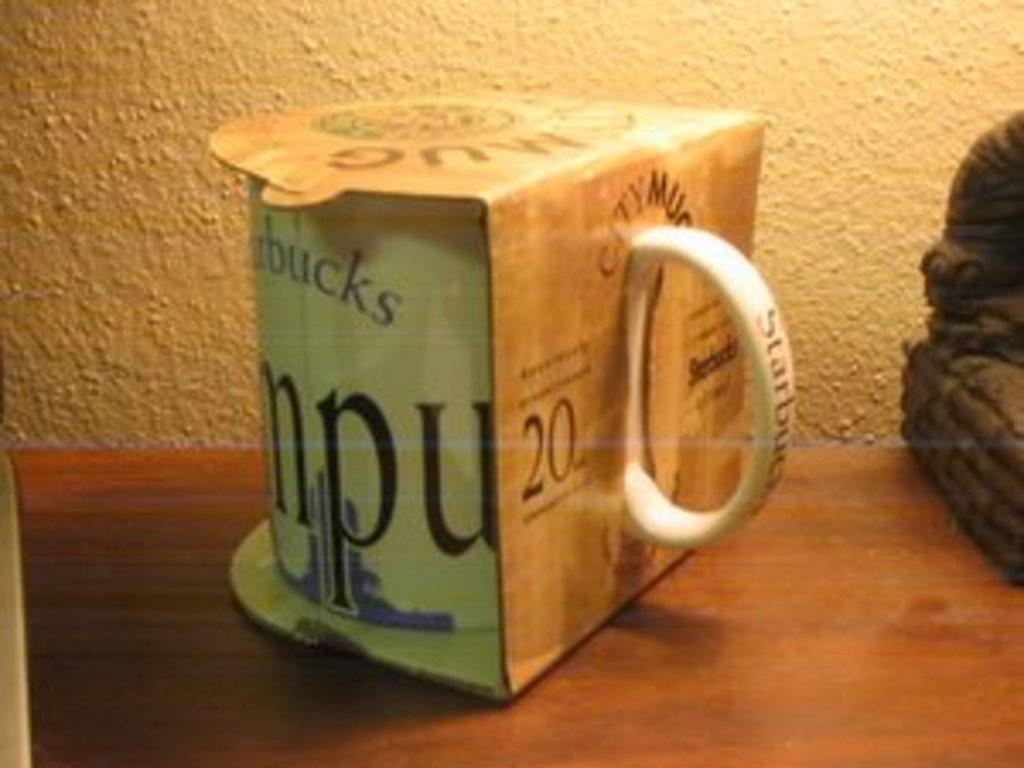<image>
Share a concise interpretation of the image provided. A mug from Starbucks that is still in its original packaging. 